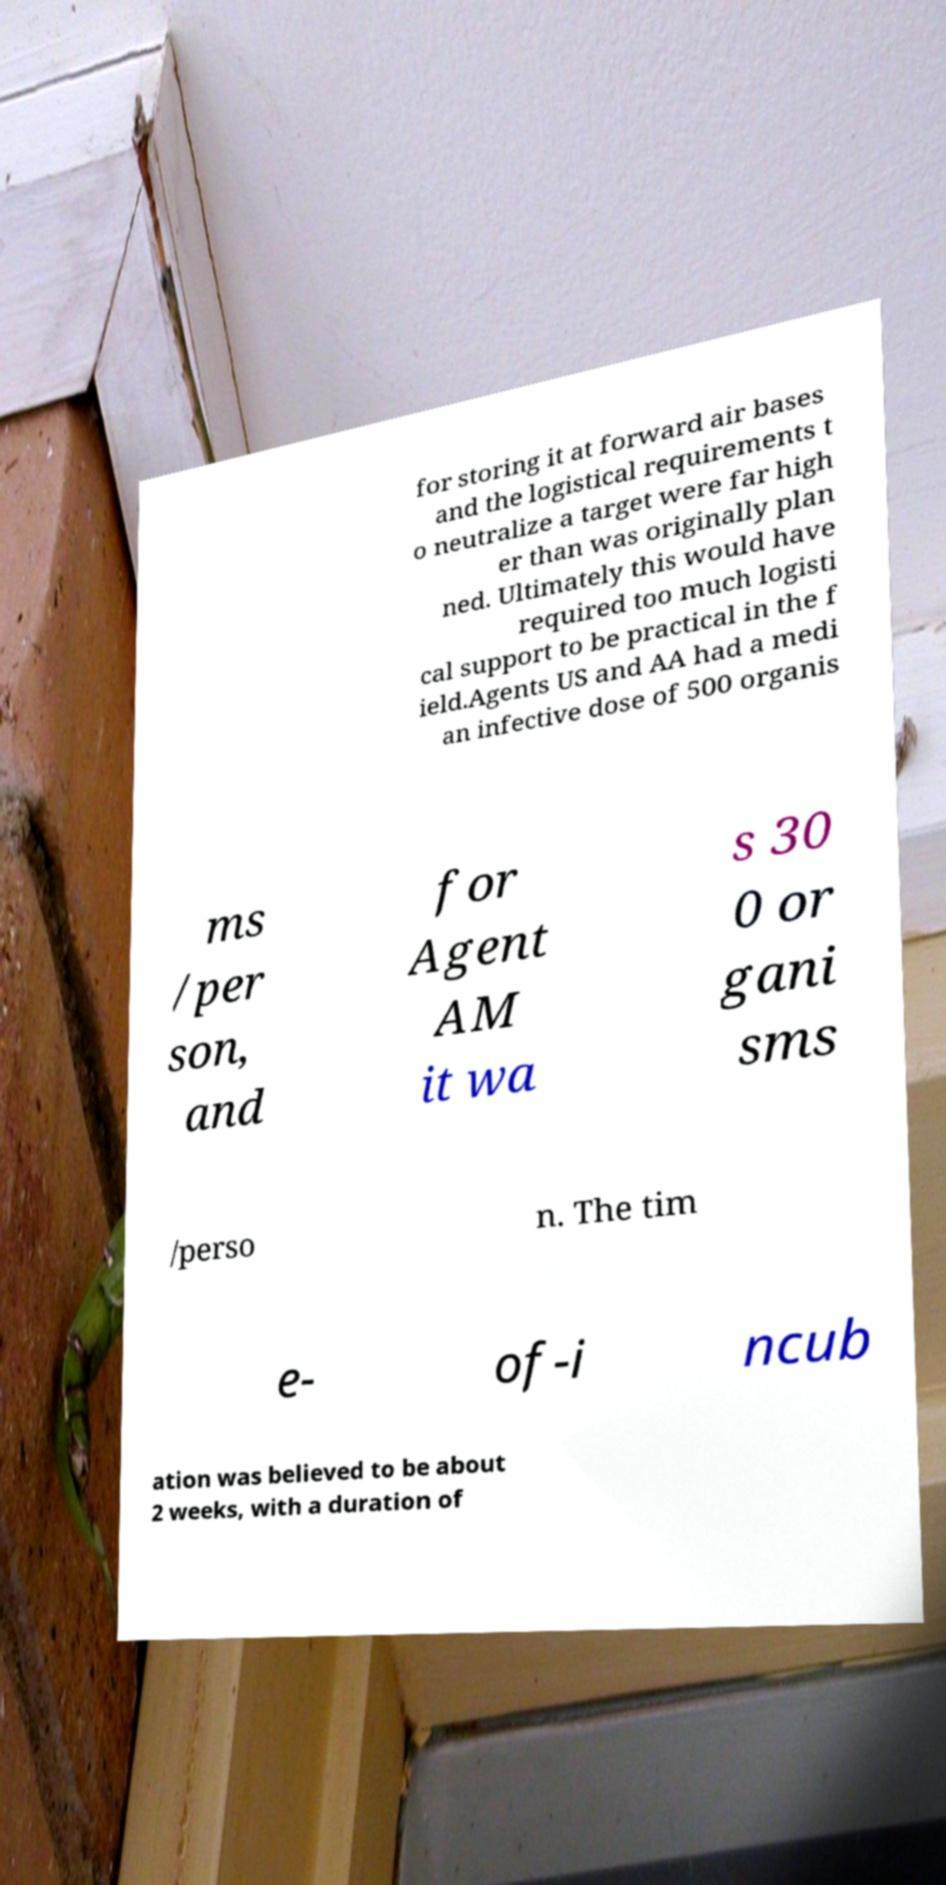Can you read and provide the text displayed in the image?This photo seems to have some interesting text. Can you extract and type it out for me? for storing it at forward air bases and the logistical requirements t o neutralize a target were far high er than was originally plan ned. Ultimately this would have required too much logisti cal support to be practical in the f ield.Agents US and AA had a medi an infective dose of 500 organis ms /per son, and for Agent AM it wa s 30 0 or gani sms /perso n. The tim e- of-i ncub ation was believed to be about 2 weeks, with a duration of 